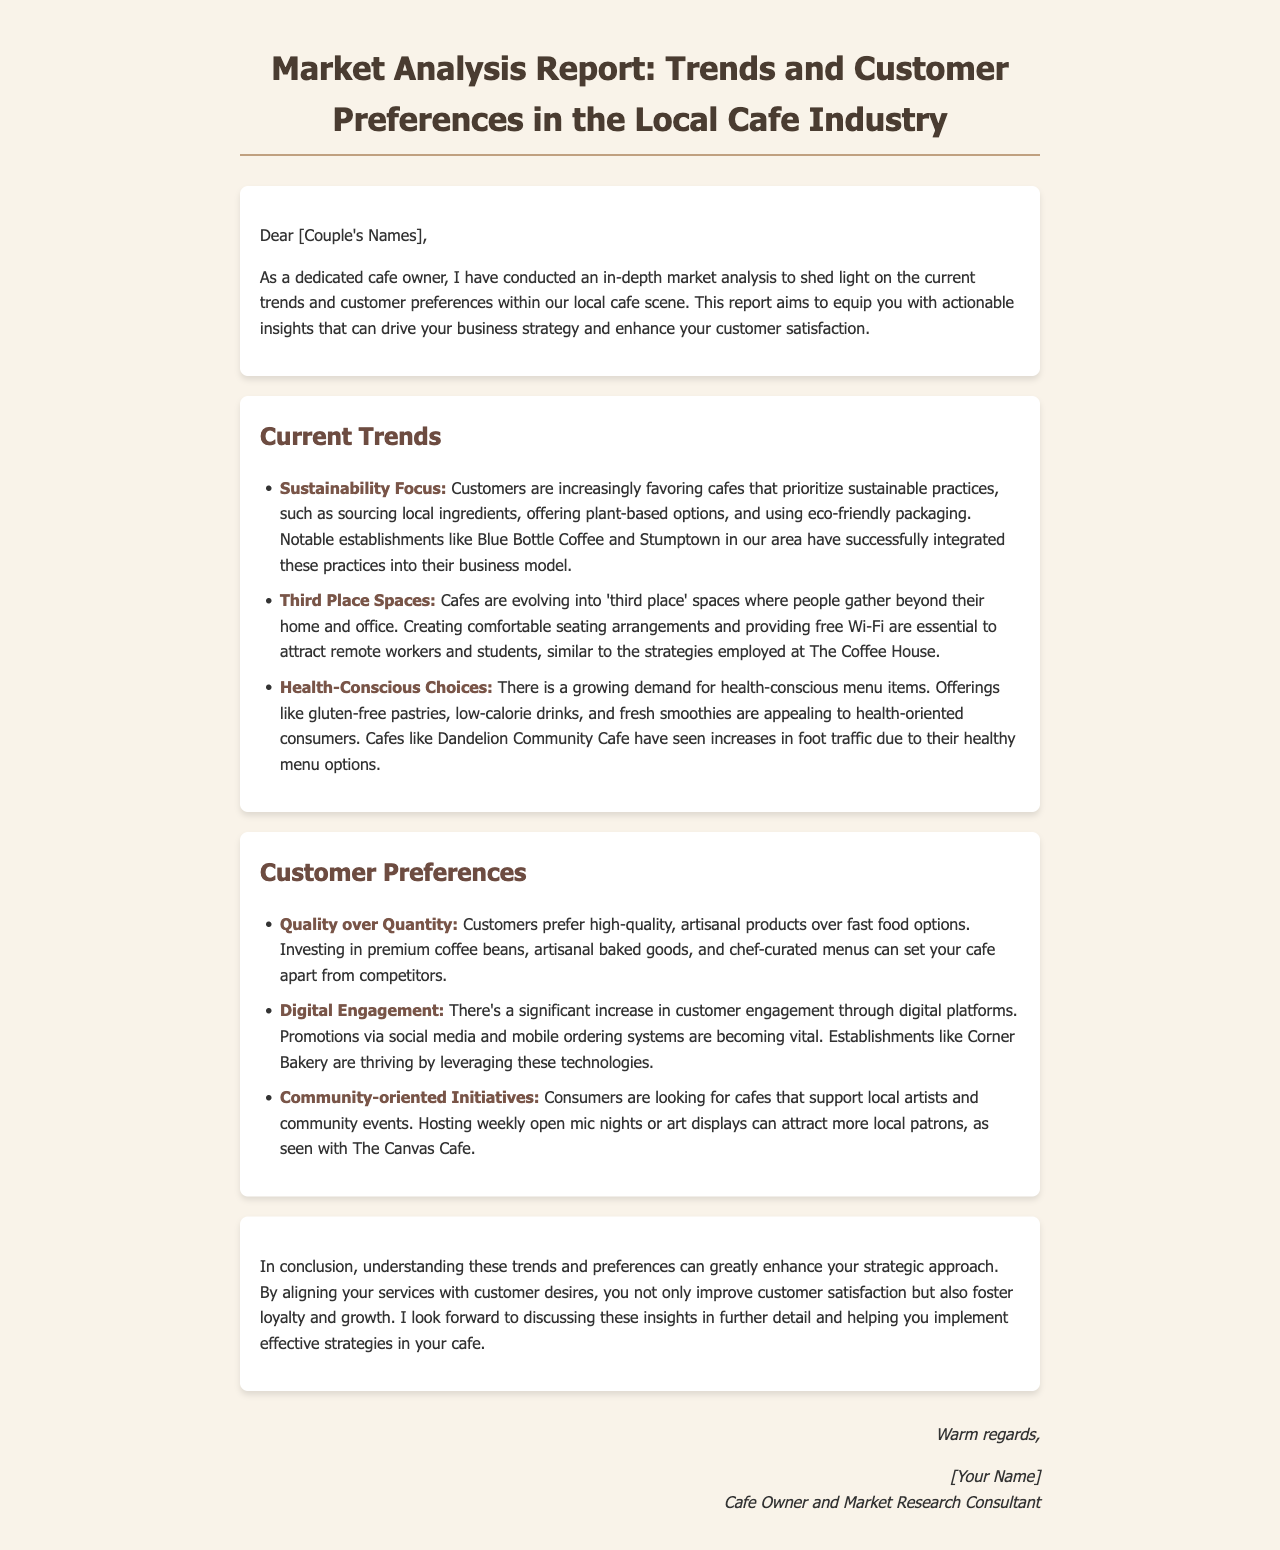What is the title of the document? The title is clearly stated in the header section of the document.
Answer: Market Analysis Report: Trends and Customer Preferences in the Local Cafe Industry What is one current trend mentioned in the report? The report lists several trends under the "Current Trends" section.
Answer: Sustainability Focus What does "third place" refer to in the context of cafes? The term is explained in the "Current Trends" section, discussing the role of cafes beyond home and office.
Answer: Gathering spaces Which cafe is noted for health-conscious choices? The report provides an example of a cafe benefiting from health-oriented menu items.
Answer: Dandelion Community Cafe What do customers prefer between quality and quantity? The document specifically highlights customer preferences in the "Customer Preferences" section.
Answer: Quality over Quantity Which digital strategy is mentioned as key for customer engagement? The significance of digital engagement is discussed in the "Customer Preferences" section.
Answer: Promotions via social media What type of events are customers looking for in cafes? The report emphasizes the importance of community initiatives that engage locals.
Answer: Community-oriented Initiatives Who is the author of the report? The author is mentioned in the closing of the document as the sender.
Answer: [Your Name] 